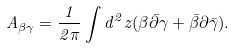Convert formula to latex. <formula><loc_0><loc_0><loc_500><loc_500>A _ { \beta \gamma } = \frac { 1 } { 2 \pi } \int d ^ { 2 } z ( \beta \bar { \partial } \gamma + \bar { \beta } \partial \bar { \gamma } ) .</formula> 